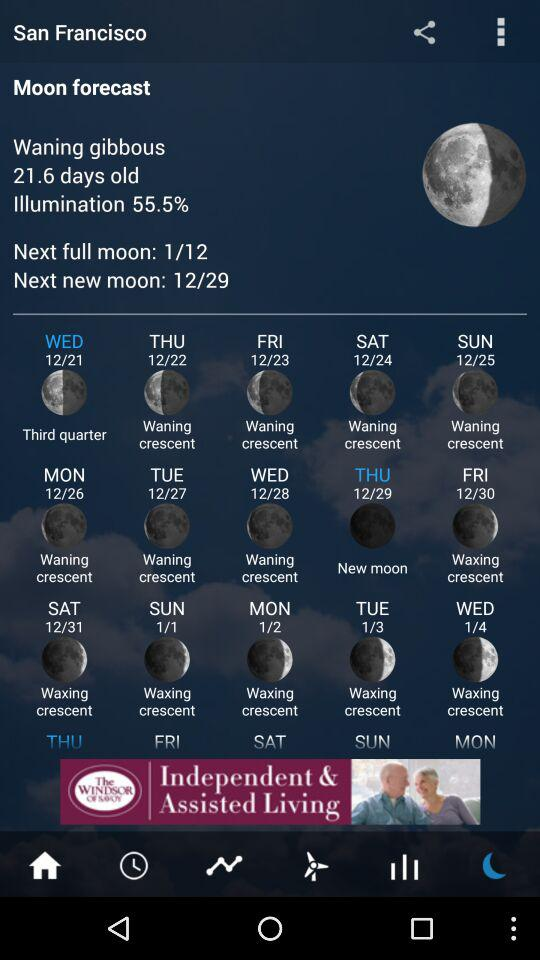What does the moon phase indicate about the best time for stargazing? The moon phases can significantly affect stargazing conditions. During a new moon, the sky is darker, making it easier to see stars and other celestial objects. Conversely, a full moon brightens the sky and can wash out faint stars, so the best time for stargazing is during or near a new moon phase.  Can the moon phases depicted in the image influence human behavior or sleep patterns? While there's no scientific consensus that the moon's phases directly influence human behavior or sleep, many cultures have anecdotal reports and beliefs that full moons can affect mood and sleep quality. Some studies suggest changes in sleep during the full moon, but more research is needed to draw definitive conclusions. 